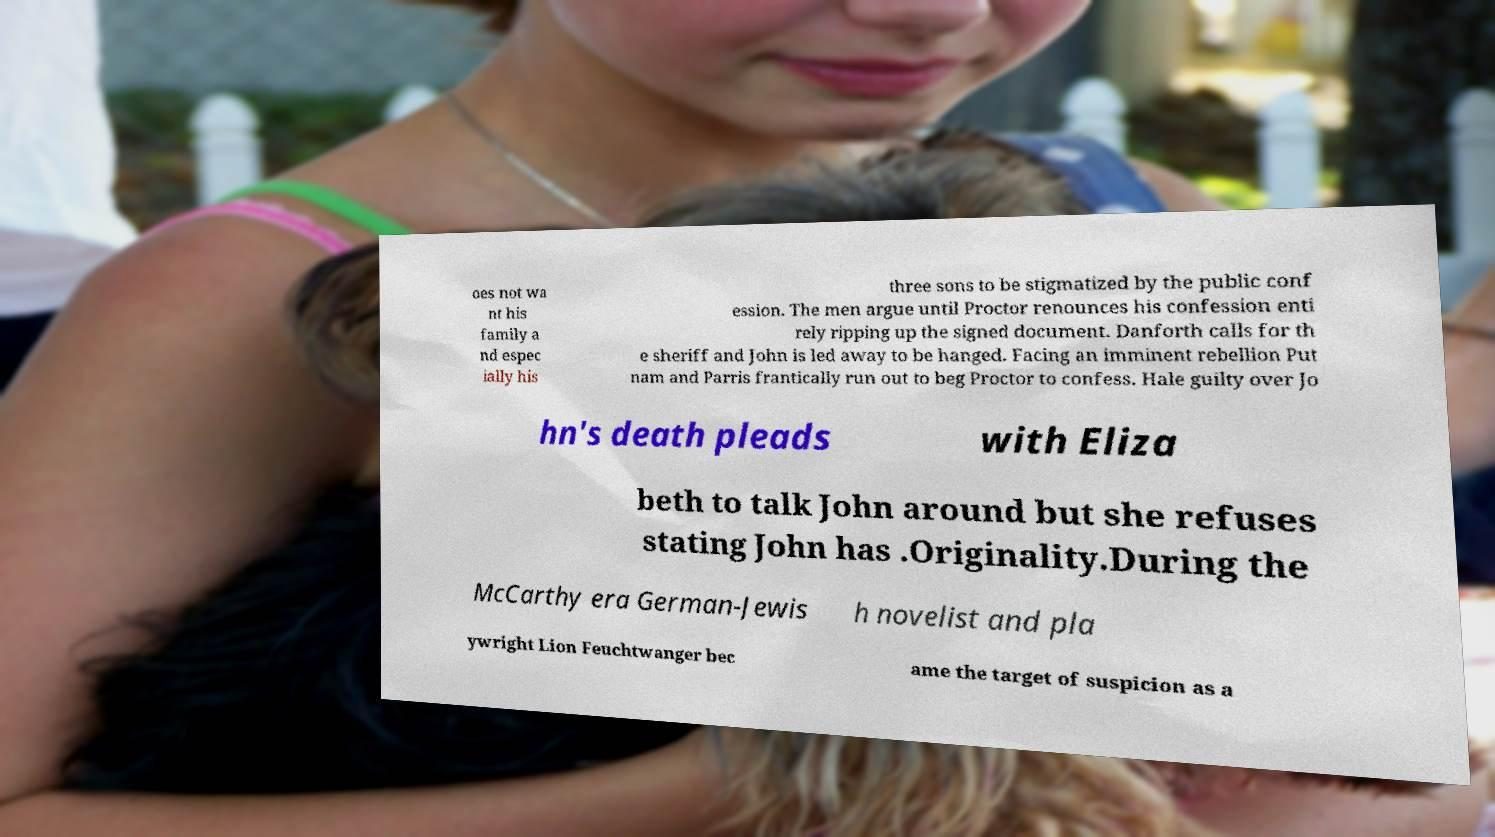What messages or text are displayed in this image? I need them in a readable, typed format. oes not wa nt his family a nd espec ially his three sons to be stigmatized by the public conf ession. The men argue until Proctor renounces his confession enti rely ripping up the signed document. Danforth calls for th e sheriff and John is led away to be hanged. Facing an imminent rebellion Put nam and Parris frantically run out to beg Proctor to confess. Hale guilty over Jo hn's death pleads with Eliza beth to talk John around but she refuses stating John has .Originality.During the McCarthy era German-Jewis h novelist and pla ywright Lion Feuchtwanger bec ame the target of suspicion as a 